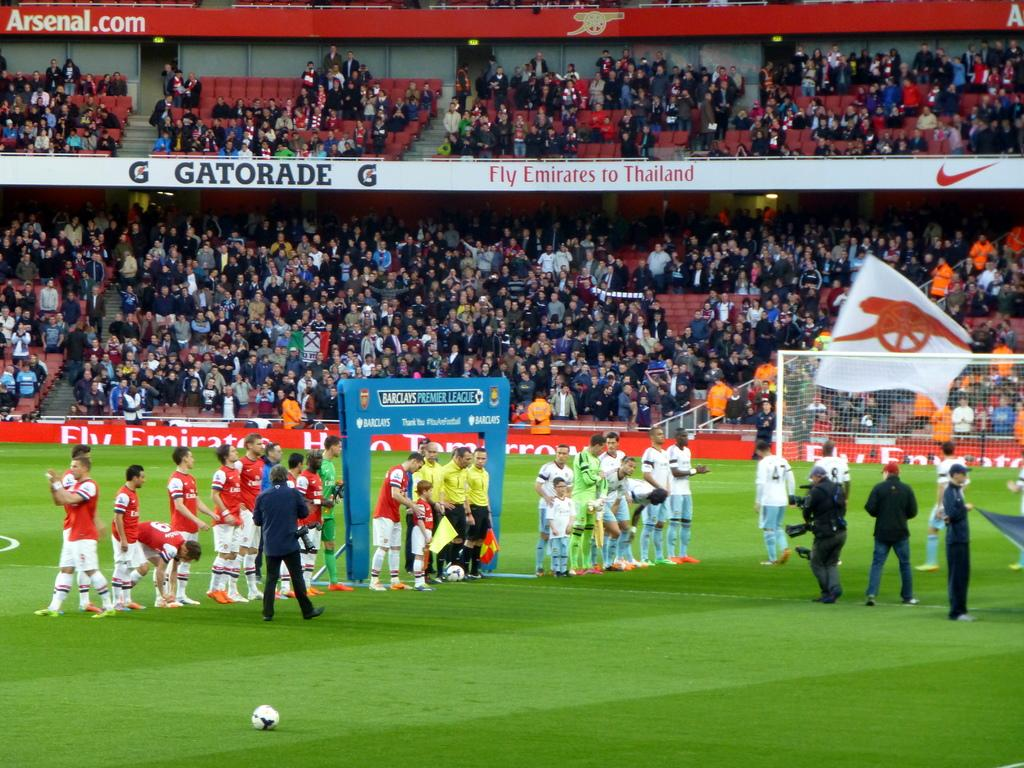<image>
Offer a succinct explanation of the picture presented. Emirates is one of the sponsors of this soccer field. 